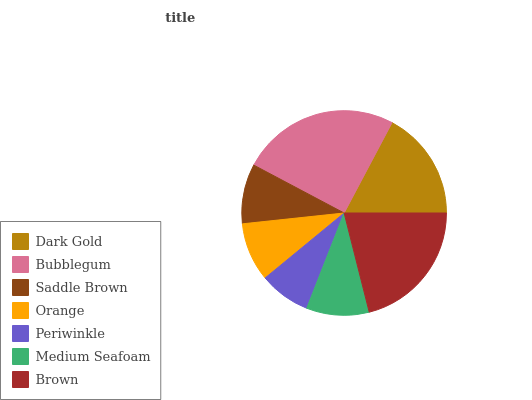Is Periwinkle the minimum?
Answer yes or no. Yes. Is Bubblegum the maximum?
Answer yes or no. Yes. Is Saddle Brown the minimum?
Answer yes or no. No. Is Saddle Brown the maximum?
Answer yes or no. No. Is Bubblegum greater than Saddle Brown?
Answer yes or no. Yes. Is Saddle Brown less than Bubblegum?
Answer yes or no. Yes. Is Saddle Brown greater than Bubblegum?
Answer yes or no. No. Is Bubblegum less than Saddle Brown?
Answer yes or no. No. Is Medium Seafoam the high median?
Answer yes or no. Yes. Is Medium Seafoam the low median?
Answer yes or no. Yes. Is Periwinkle the high median?
Answer yes or no. No. Is Dark Gold the low median?
Answer yes or no. No. 